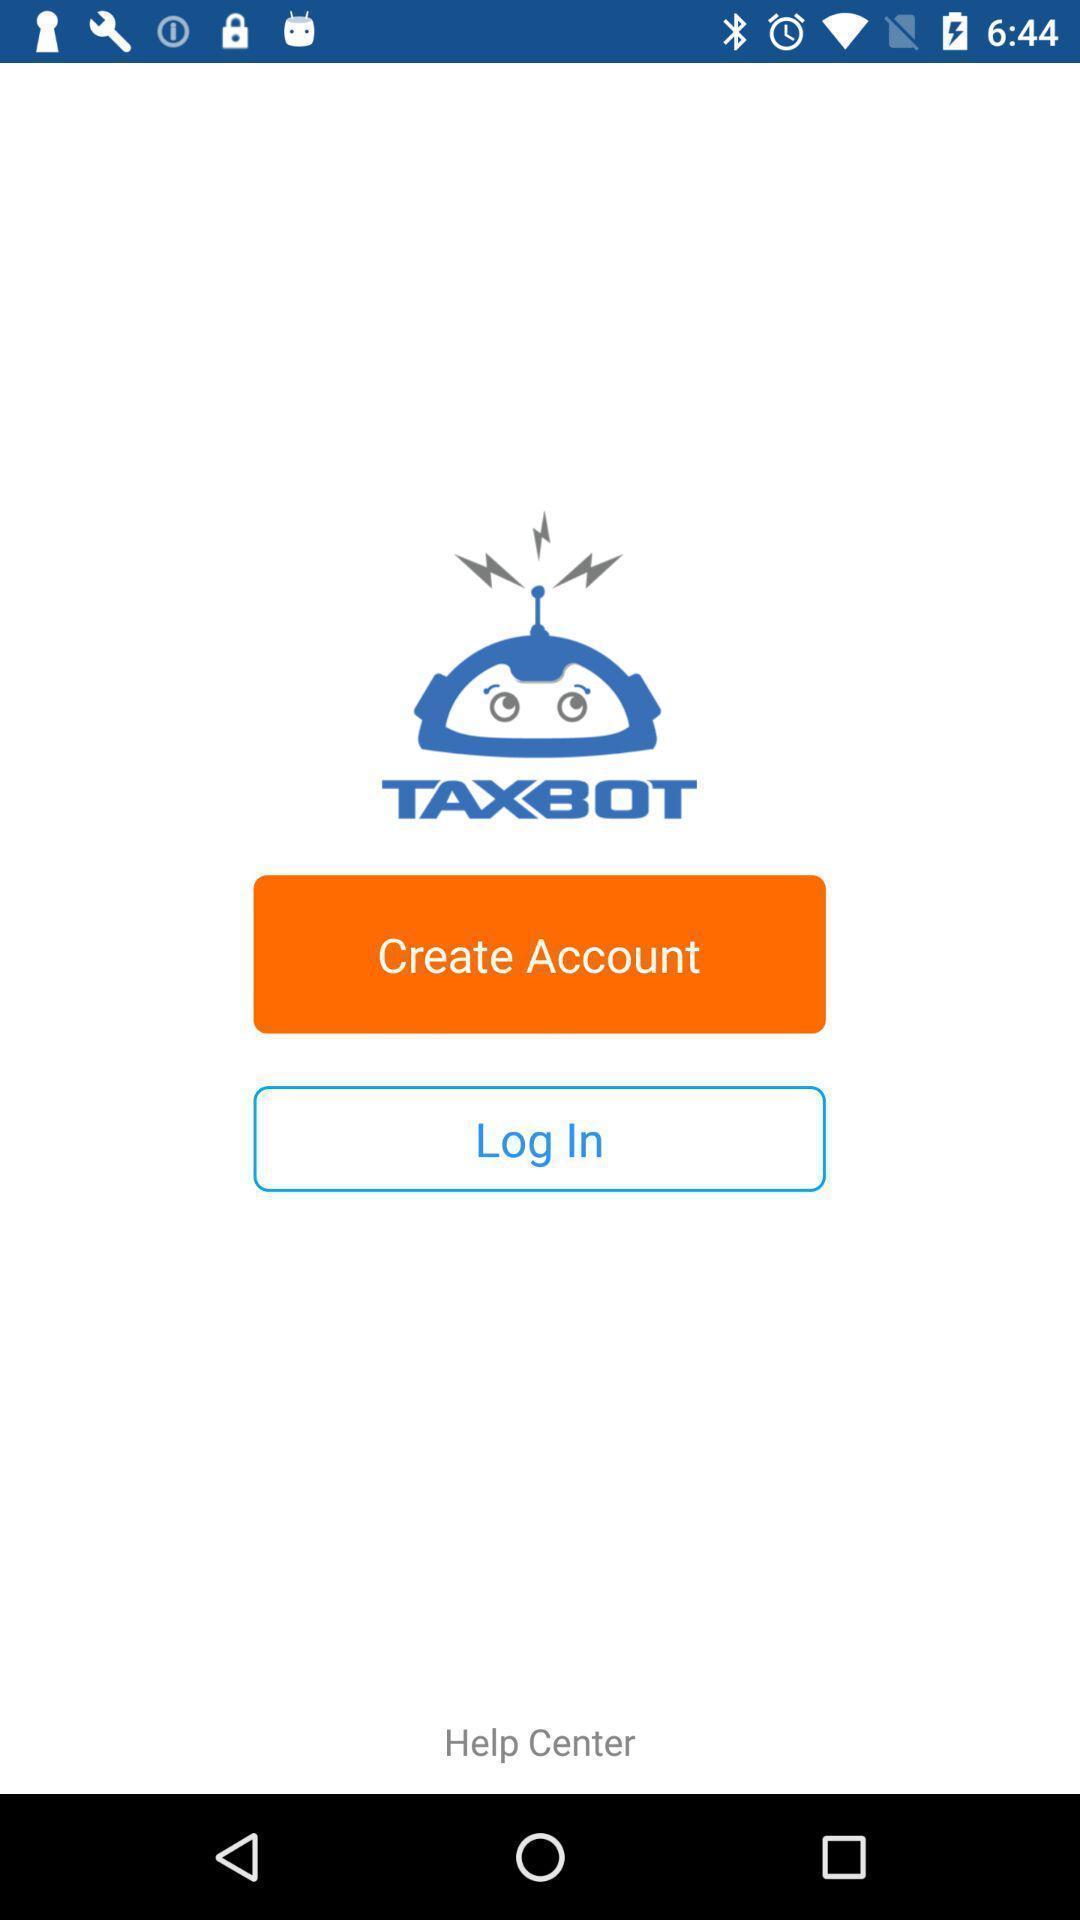Describe the content in this image. Startup page to access the application. 